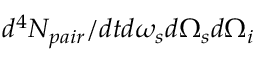<formula> <loc_0><loc_0><loc_500><loc_500>d ^ { 4 } N _ { p a i r } / d t d \omega _ { s } d \Omega _ { s } d \Omega _ { i }</formula> 